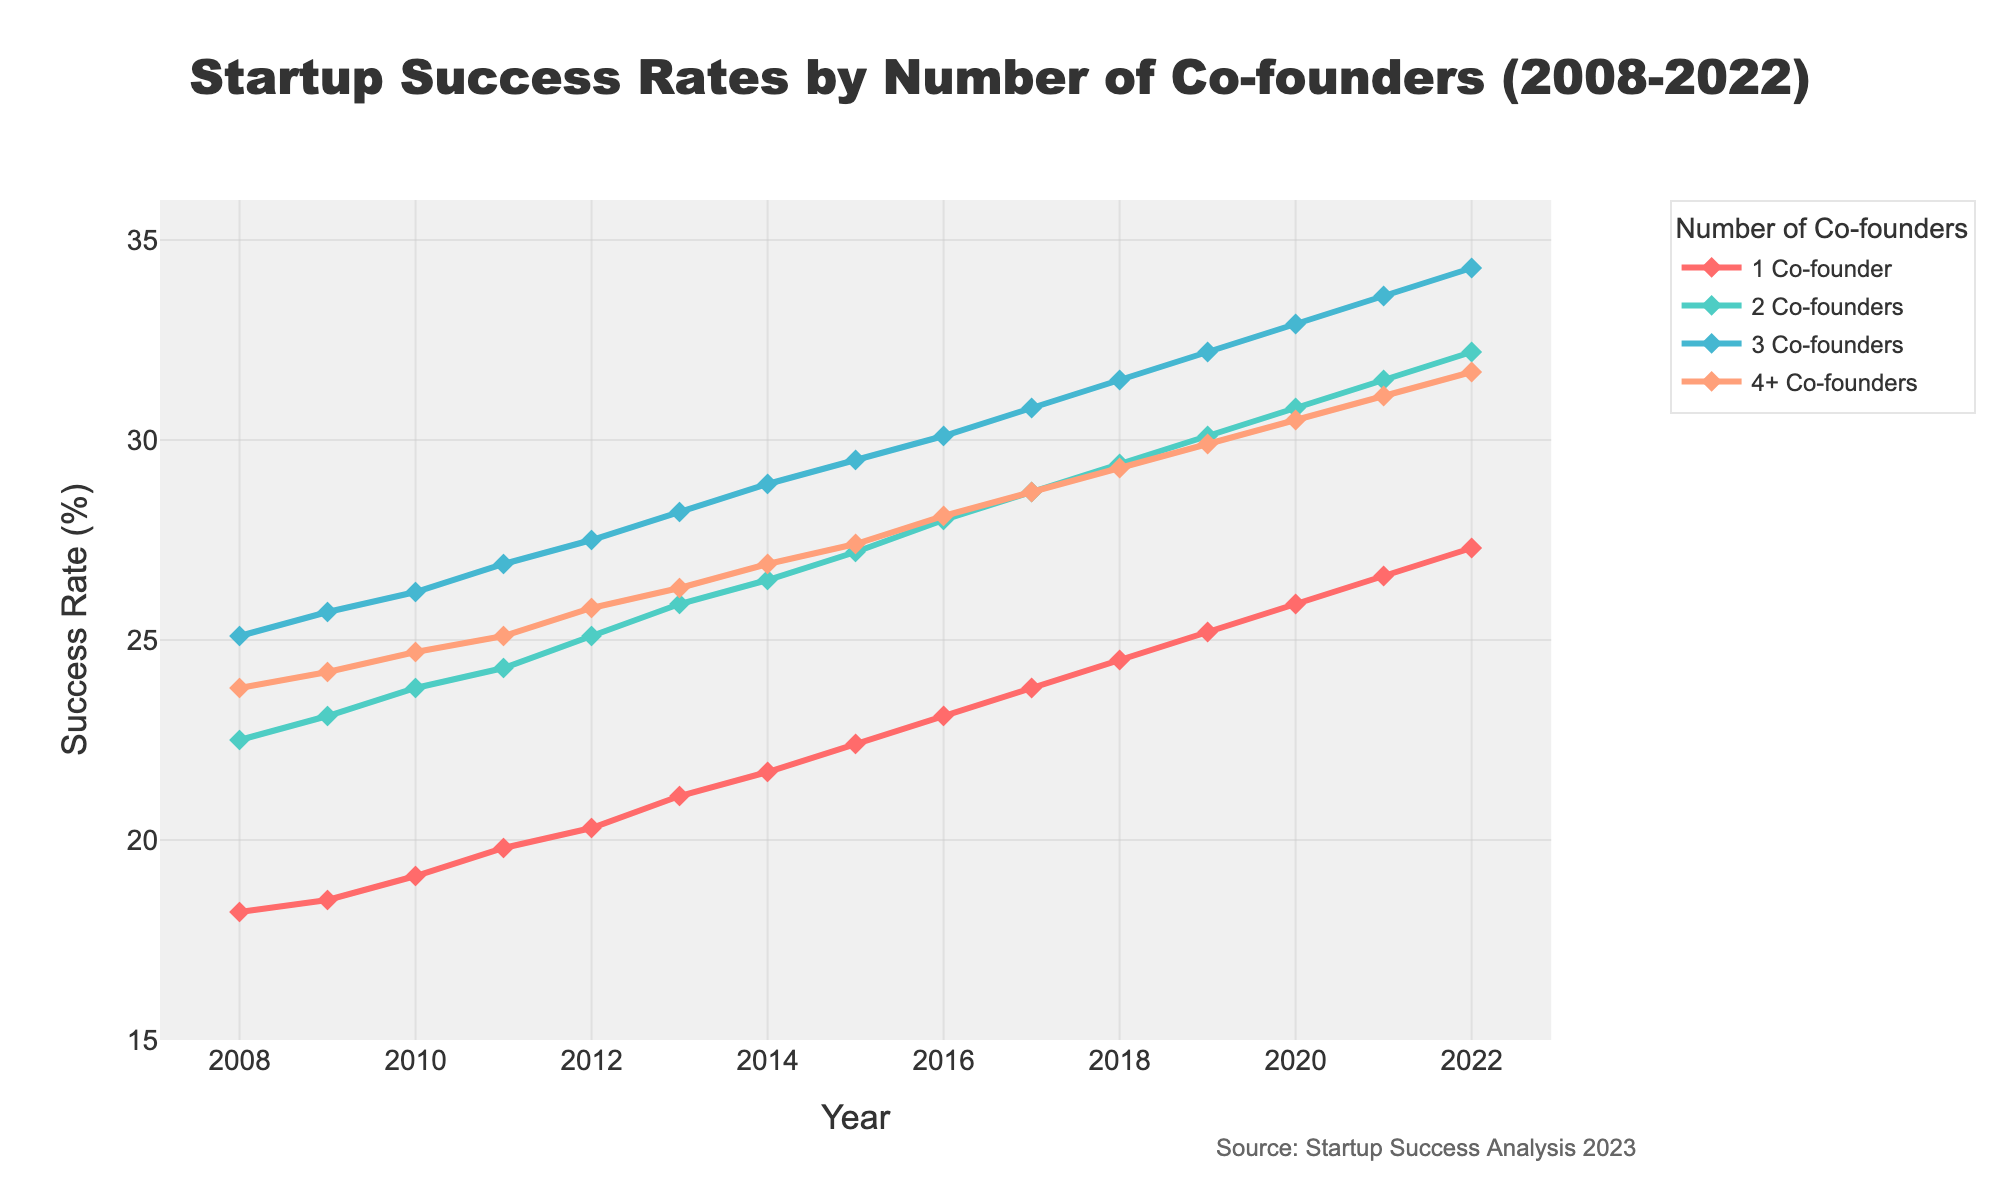How many years have success rates increased for startups with 3 co-founders? The data for startups with 3 co-founders shows a continuous increase every year from 2008 (25.1%) to 2022 (34.3%). There are 15 years from 2008 to 2022.
Answer: 15 years Which year shows the highest success rate for startups with 2 co-founders, and what is the rate? By inspecting the line corresponding to 2 co-founders, the highest success rate appears in 2022 at 32.2%.
Answer: 2022, 32.2% What is the difference in success rates between startups with 1 and 4+ co-founders in 2015? In 2015, the success rate for 1 co-founder is 22.4% while for 4+ co-founders it is 27.4%. The difference is 27.4% - 22.4% = 5.0%.
Answer: 5.0% Compare the trend in success rates for 1 co-founder and 3 co-founders over the entire period. Which has a steeper increase? The success rate for 1 co-founder increases from 18.2% in 2008 to 27.3% in 2022, a difference of 9.1%. For 3 co-founders, it increases from 25.1% in 2008 to 34.3% in 2022, a difference of 9.2%. The rate of increase for 3 co-founders is slightly steeper.
Answer: 3 co-founders What are the success rates in 2010 for 2 co-founders and 4+ co-founders, and which is higher? In 2010, the success rate for 2 co-founders is 23.8%, while for 4+ co-founders it is 24.7%. The success rate for 4+ co-founders is higher.
Answer: 4+ co-founders, 24.7% Calculate the average success rate across all categories in 2017. The success rates for 2017 are: 1 co-founder - 23.8%, 2 co-founders - 28.7%, 3 co-founders - 30.8%, 4+ co-founders - 28.7%. The average is (23.8% + 28.7% + 30.8% + 28.7%) / 4 = 28.0%.
Answer: 28.0% How does the success rate of startups with 1 co-founder change from 2011 to 2018? In 2011, the success rate for 1 co-founder is 19.8%, and in 2018 it is 24.5%. The change over this period is 24.5% - 19.8% = 4.7%.
Answer: 4.7% What is the general trend for the success rates of all categories from 2008 to 2022? The trend for all categories shows an increase in success rates over time. Each line for 1 co-founder, 2 co-founders, 3 co-founders, and 4+ co-founders shows a positive slope from 2008 to 2022.
Answer: Increasing Which color represents the success rate for startups with 3 co-founders? The color representing the success rate for startups with 3 co-founders is visible in shades and positions in the legend. It is indicated by the color that maps to success rates ranging from 25.1% to 34.3%. It is a shade of light blue.
Answer: Light blue 